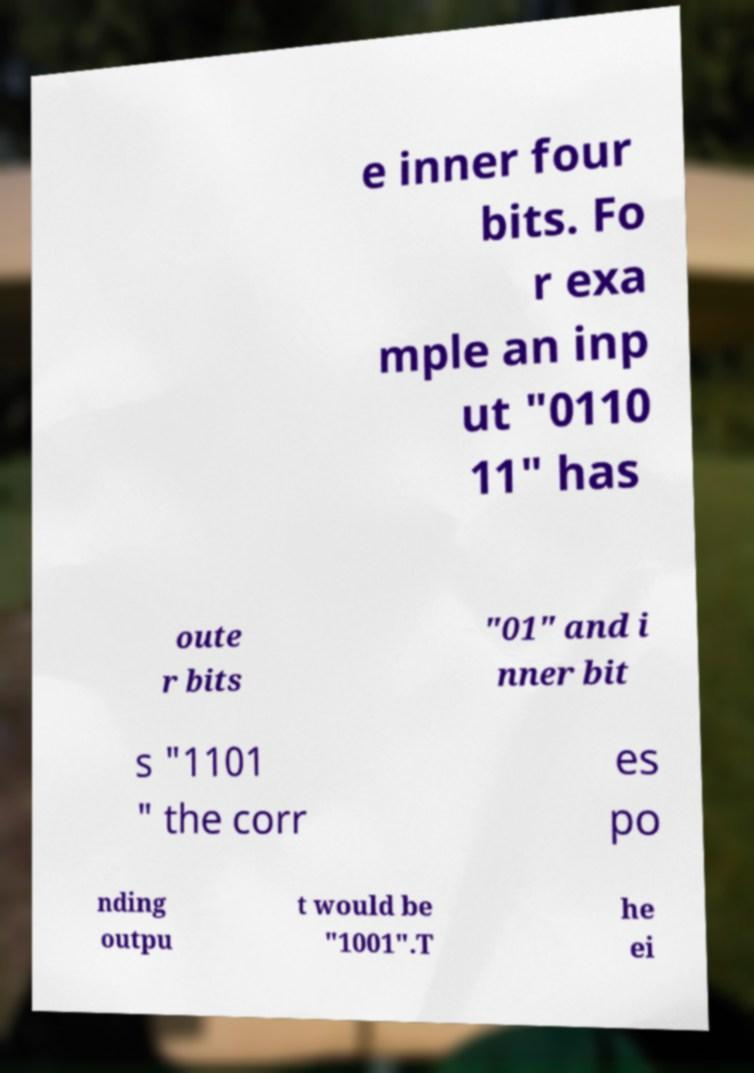I need the written content from this picture converted into text. Can you do that? e inner four bits. Fo r exa mple an inp ut "0110 11" has oute r bits "01" and i nner bit s "1101 " the corr es po nding outpu t would be "1001".T he ei 